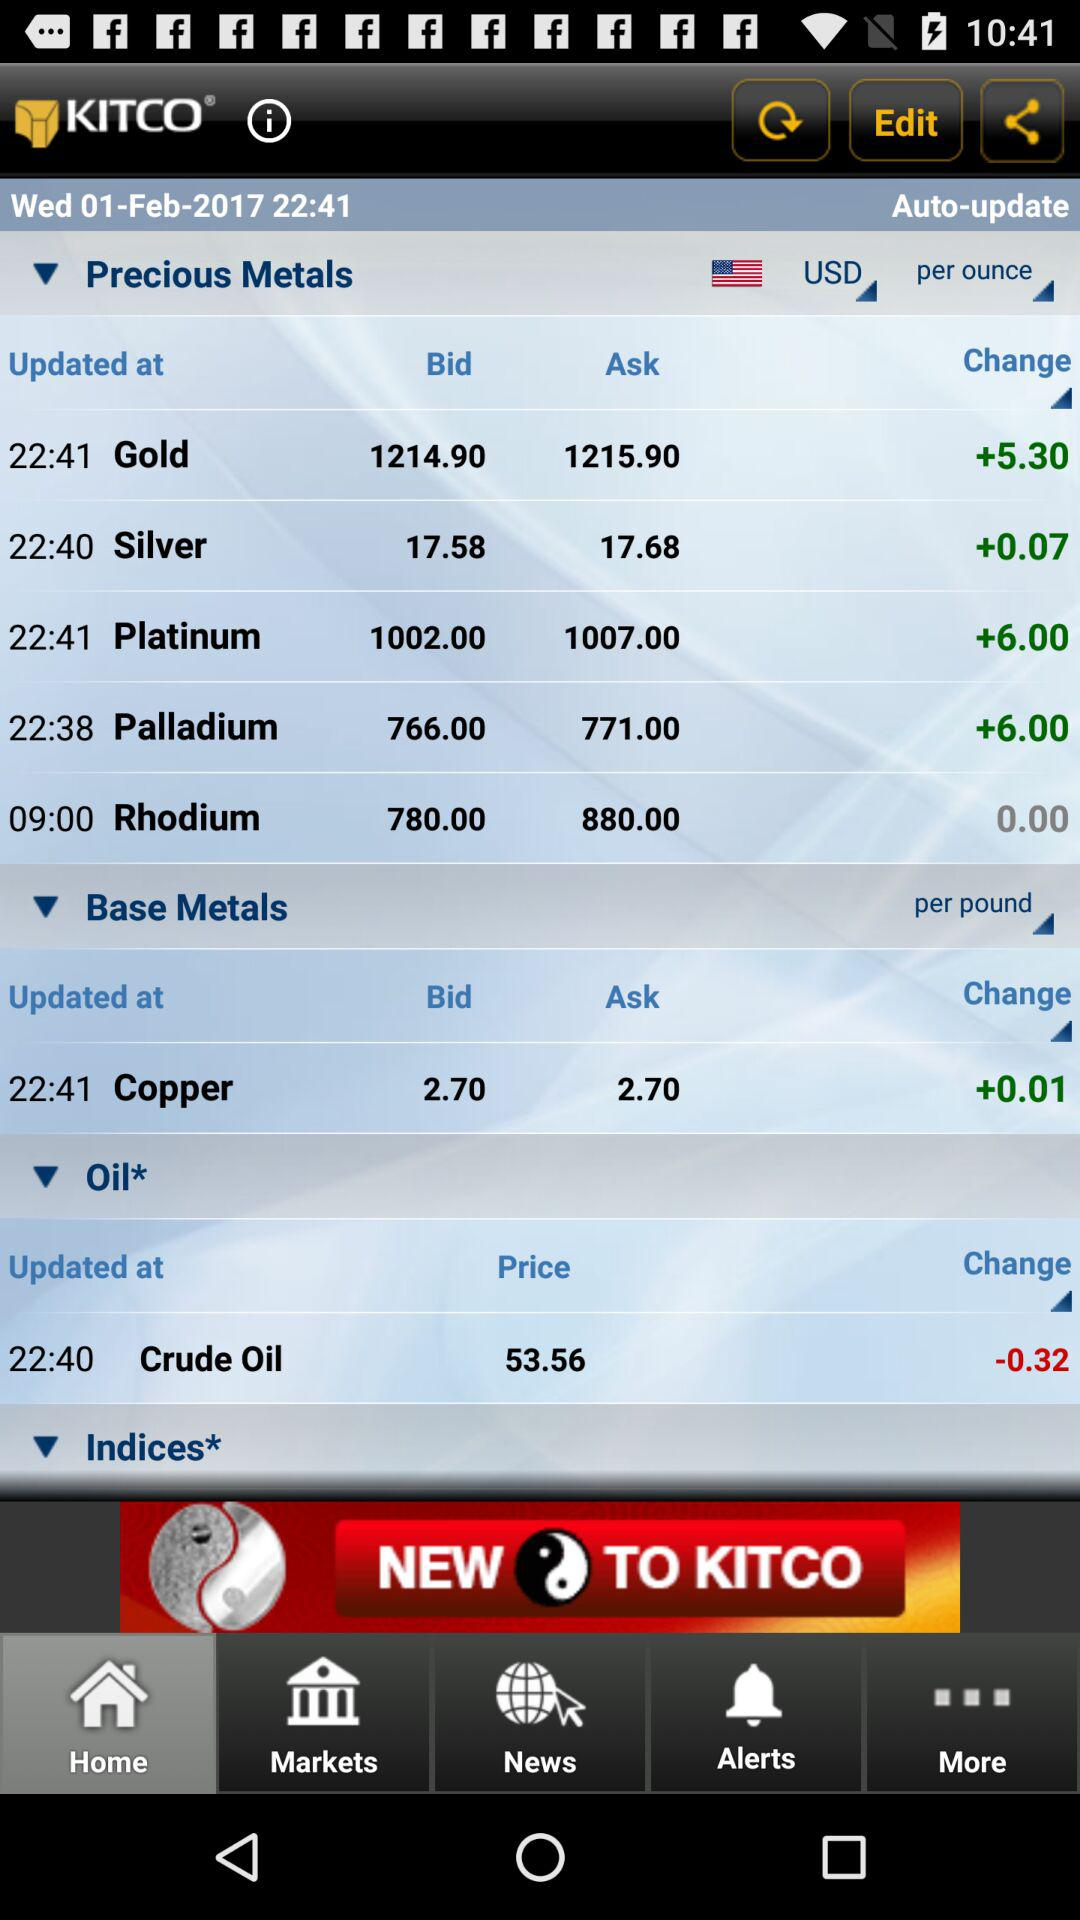What is the bid for gold? The bid for gold is 1214.90. 